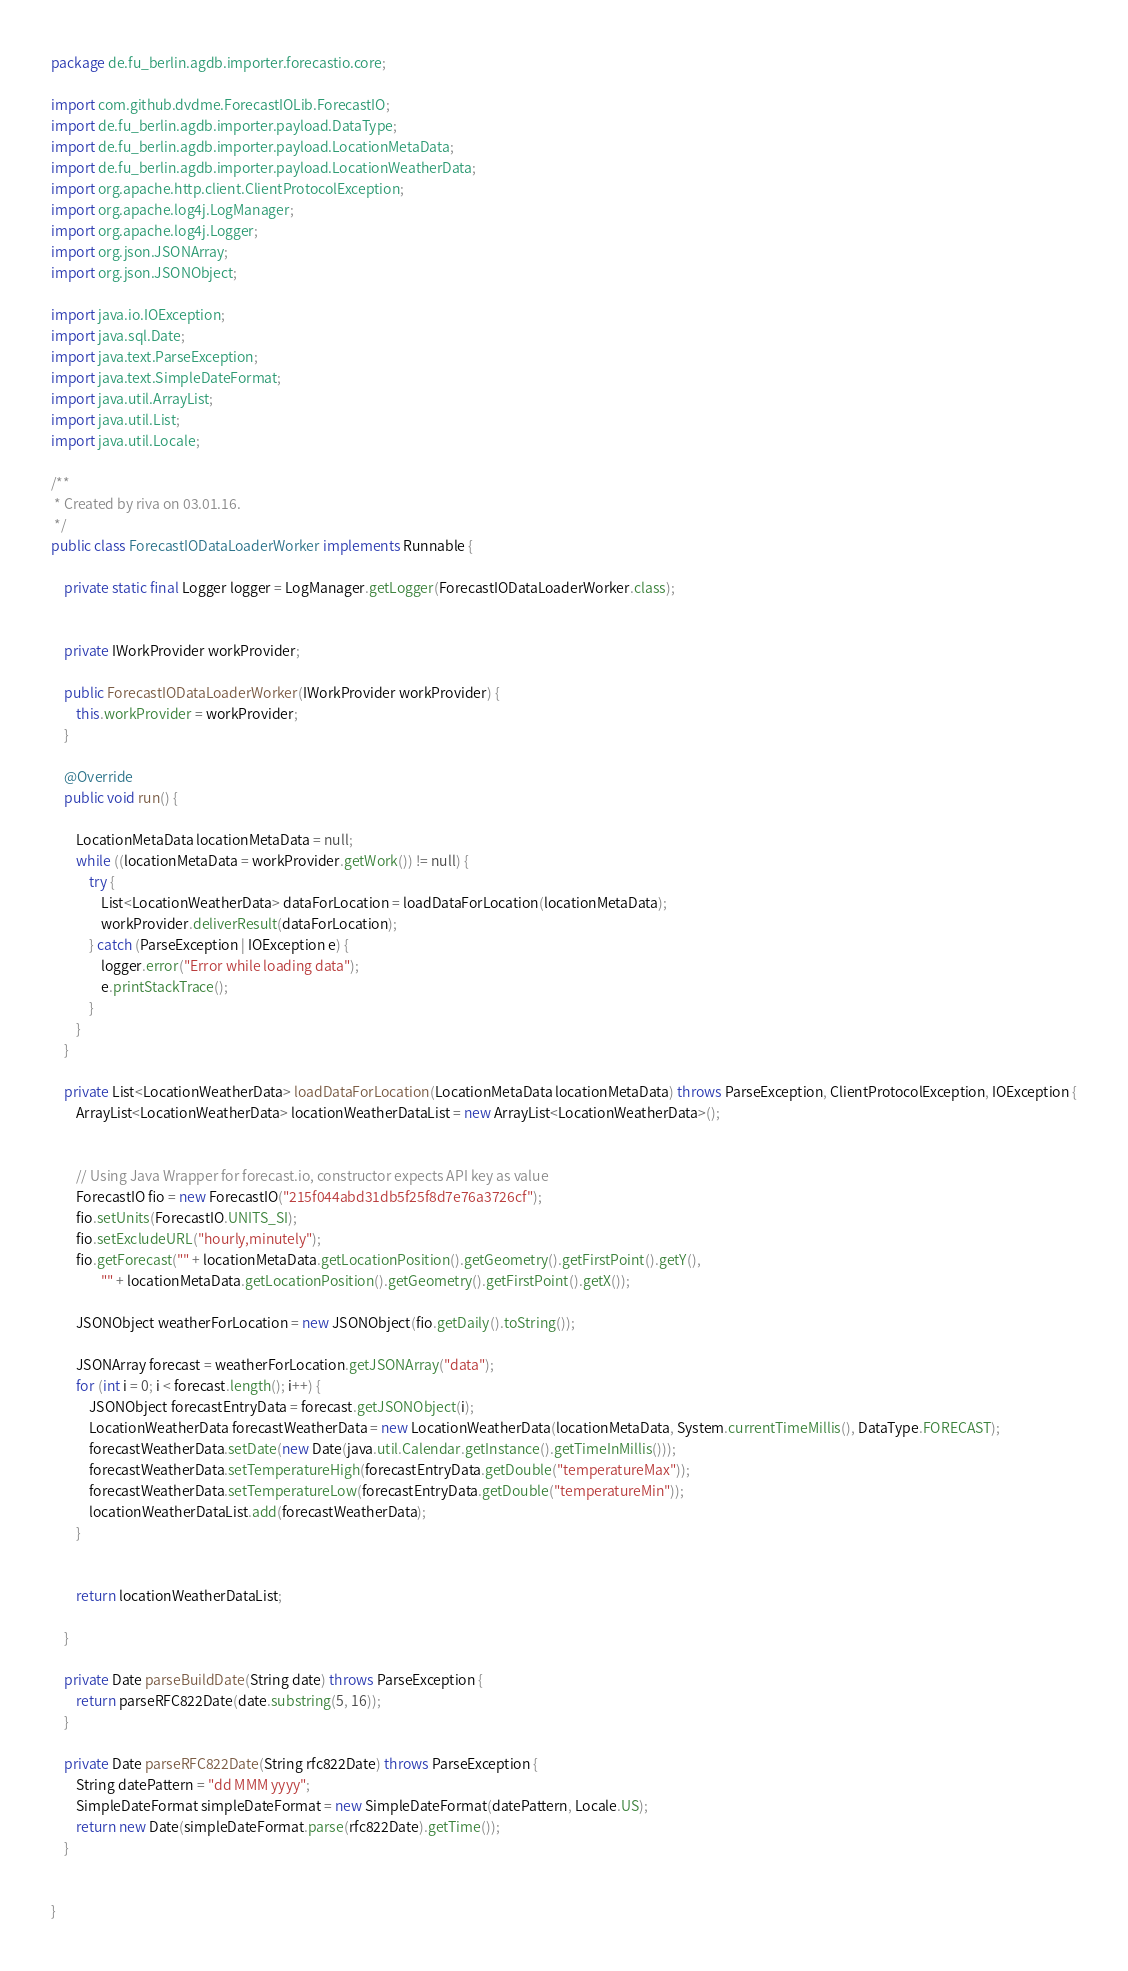Convert code to text. <code><loc_0><loc_0><loc_500><loc_500><_Java_>package de.fu_berlin.agdb.importer.forecastio.core;

import com.github.dvdme.ForecastIOLib.ForecastIO;
import de.fu_berlin.agdb.importer.payload.DataType;
import de.fu_berlin.agdb.importer.payload.LocationMetaData;
import de.fu_berlin.agdb.importer.payload.LocationWeatherData;
import org.apache.http.client.ClientProtocolException;
import org.apache.log4j.LogManager;
import org.apache.log4j.Logger;
import org.json.JSONArray;
import org.json.JSONObject;

import java.io.IOException;
import java.sql.Date;
import java.text.ParseException;
import java.text.SimpleDateFormat;
import java.util.ArrayList;
import java.util.List;
import java.util.Locale;

/**
 * Created by riva on 03.01.16.
 */
public class ForecastIODataLoaderWorker implements Runnable {

    private static final Logger logger = LogManager.getLogger(ForecastIODataLoaderWorker.class);


    private IWorkProvider workProvider;

    public ForecastIODataLoaderWorker(IWorkProvider workProvider) {
        this.workProvider = workProvider;
    }

    @Override
    public void run() {

        LocationMetaData locationMetaData = null;
        while ((locationMetaData = workProvider.getWork()) != null) {
            try {
                List<LocationWeatherData> dataForLocation = loadDataForLocation(locationMetaData);
                workProvider.deliverResult(dataForLocation);
            } catch (ParseException | IOException e) {
                logger.error("Error while loading data");
                e.printStackTrace();
            }
        }
    }

    private List<LocationWeatherData> loadDataForLocation(LocationMetaData locationMetaData) throws ParseException, ClientProtocolException, IOException {
        ArrayList<LocationWeatherData> locationWeatherDataList = new ArrayList<LocationWeatherData>();


        // Using Java Wrapper for forecast.io, constructor expects API key as value
        ForecastIO fio = new ForecastIO("215f044abd31db5f25f8d7e76a3726cf");
        fio.setUnits(ForecastIO.UNITS_SI);
        fio.setExcludeURL("hourly,minutely");
        fio.getForecast("" + locationMetaData.getLocationPosition().getGeometry().getFirstPoint().getY(),
                "" + locationMetaData.getLocationPosition().getGeometry().getFirstPoint().getX());

        JSONObject weatherForLocation = new JSONObject(fio.getDaily().toString());

        JSONArray forecast = weatherForLocation.getJSONArray("data");
        for (int i = 0; i < forecast.length(); i++) {
            JSONObject forecastEntryData = forecast.getJSONObject(i);
            LocationWeatherData forecastWeatherData = new LocationWeatherData(locationMetaData, System.currentTimeMillis(), DataType.FORECAST);
            forecastWeatherData.setDate(new Date(java.util.Calendar.getInstance().getTimeInMillis()));
            forecastWeatherData.setTemperatureHigh(forecastEntryData.getDouble("temperatureMax"));
            forecastWeatherData.setTemperatureLow(forecastEntryData.getDouble("temperatureMin"));
            locationWeatherDataList.add(forecastWeatherData);
        }


        return locationWeatherDataList;

    }

    private Date parseBuildDate(String date) throws ParseException {
        return parseRFC822Date(date.substring(5, 16));
    }

    private Date parseRFC822Date(String rfc822Date) throws ParseException {
        String datePattern = "dd MMM yyyy";
        SimpleDateFormat simpleDateFormat = new SimpleDateFormat(datePattern, Locale.US);
        return new Date(simpleDateFormat.parse(rfc822Date).getTime());
    }


}
</code> 